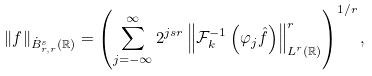Convert formula to latex. <formula><loc_0><loc_0><loc_500><loc_500>\| f \| _ { \dot { B } ^ { s } _ { r , r } ( \mathbb { R } ) } = \left ( \sum _ { j = - \infty } ^ { \infty } 2 ^ { j s r } \left \| \mathcal { F } ^ { - 1 } _ { k } \left ( \varphi _ { j } \hat { f } \right ) \right \| _ { L ^ { r } ( \mathbb { R } ) } ^ { r } \right ) ^ { 1 / r } ,</formula> 